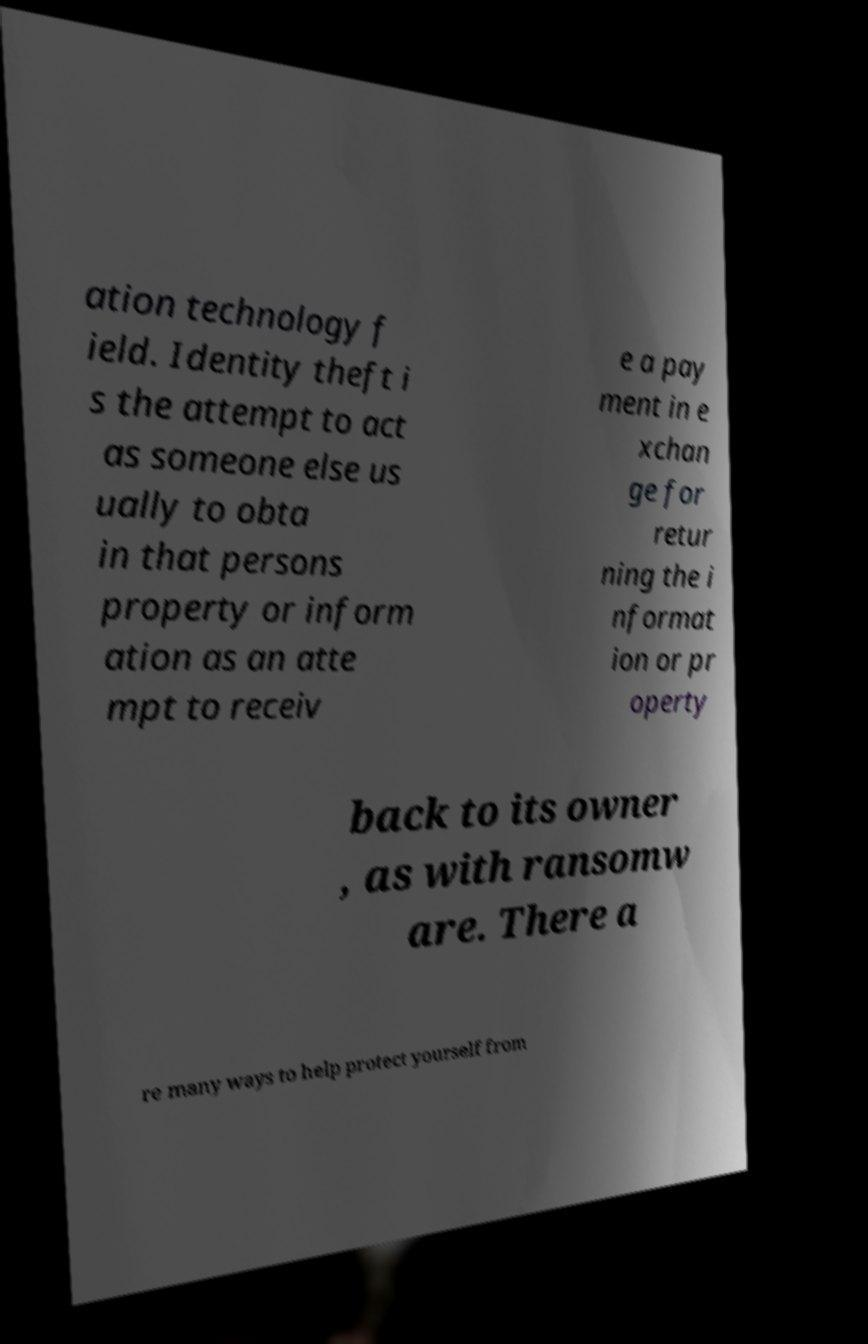Please identify and transcribe the text found in this image. ation technology f ield. Identity theft i s the attempt to act as someone else us ually to obta in that persons property or inform ation as an atte mpt to receiv e a pay ment in e xchan ge for retur ning the i nformat ion or pr operty back to its owner , as with ransomw are. There a re many ways to help protect yourself from 